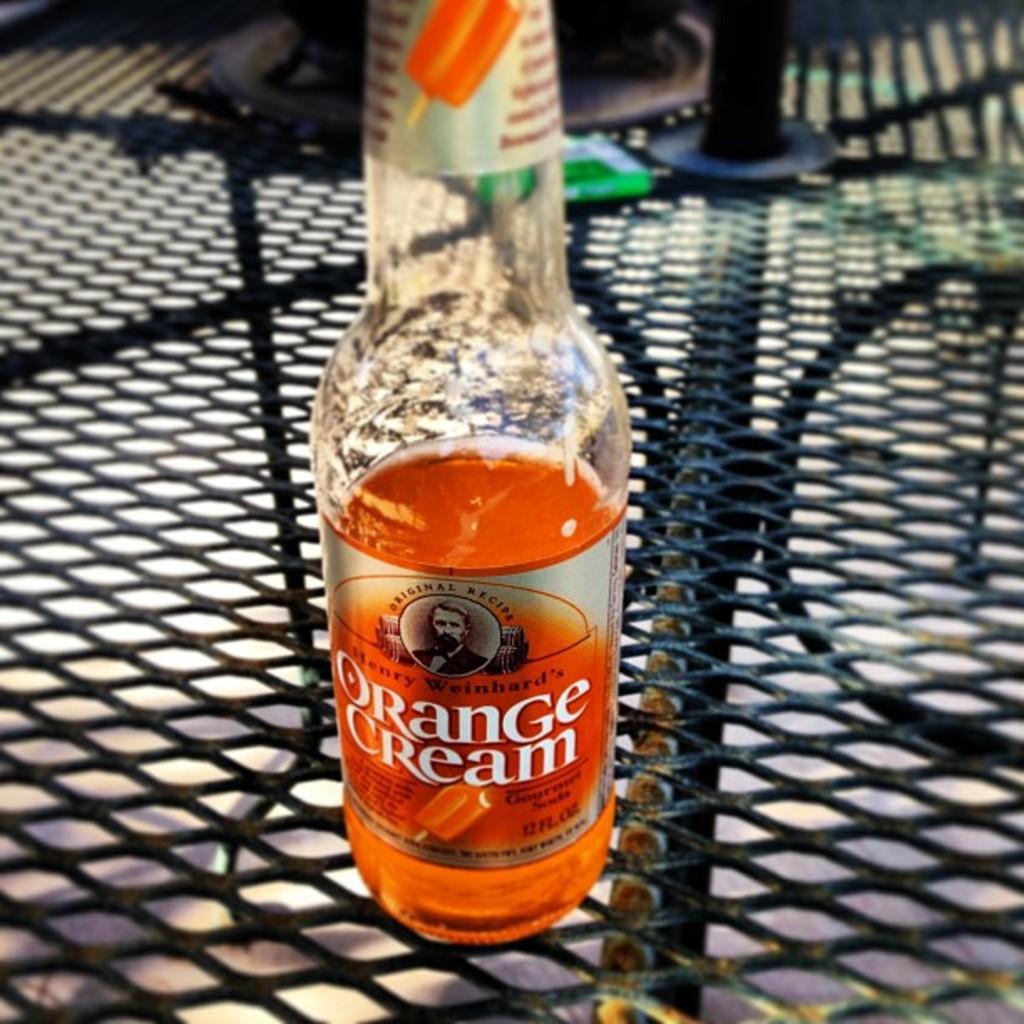What is the recipe type?
Keep it short and to the point. Orange cream. 